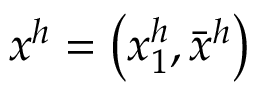Convert formula to latex. <formula><loc_0><loc_0><loc_500><loc_500>x ^ { h } = \left ( x _ { 1 } ^ { h } , { \bar { x } } ^ { h } \right )</formula> 